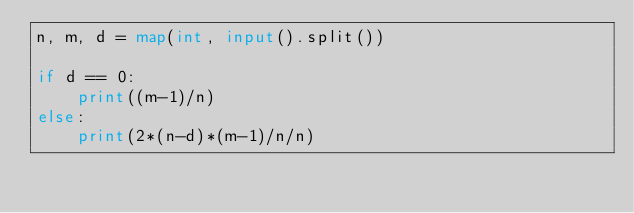Convert code to text. <code><loc_0><loc_0><loc_500><loc_500><_Python_>n, m, d = map(int, input().split())

if d == 0:
    print((m-1)/n)
else:
    print(2*(n-d)*(m-1)/n/n)</code> 